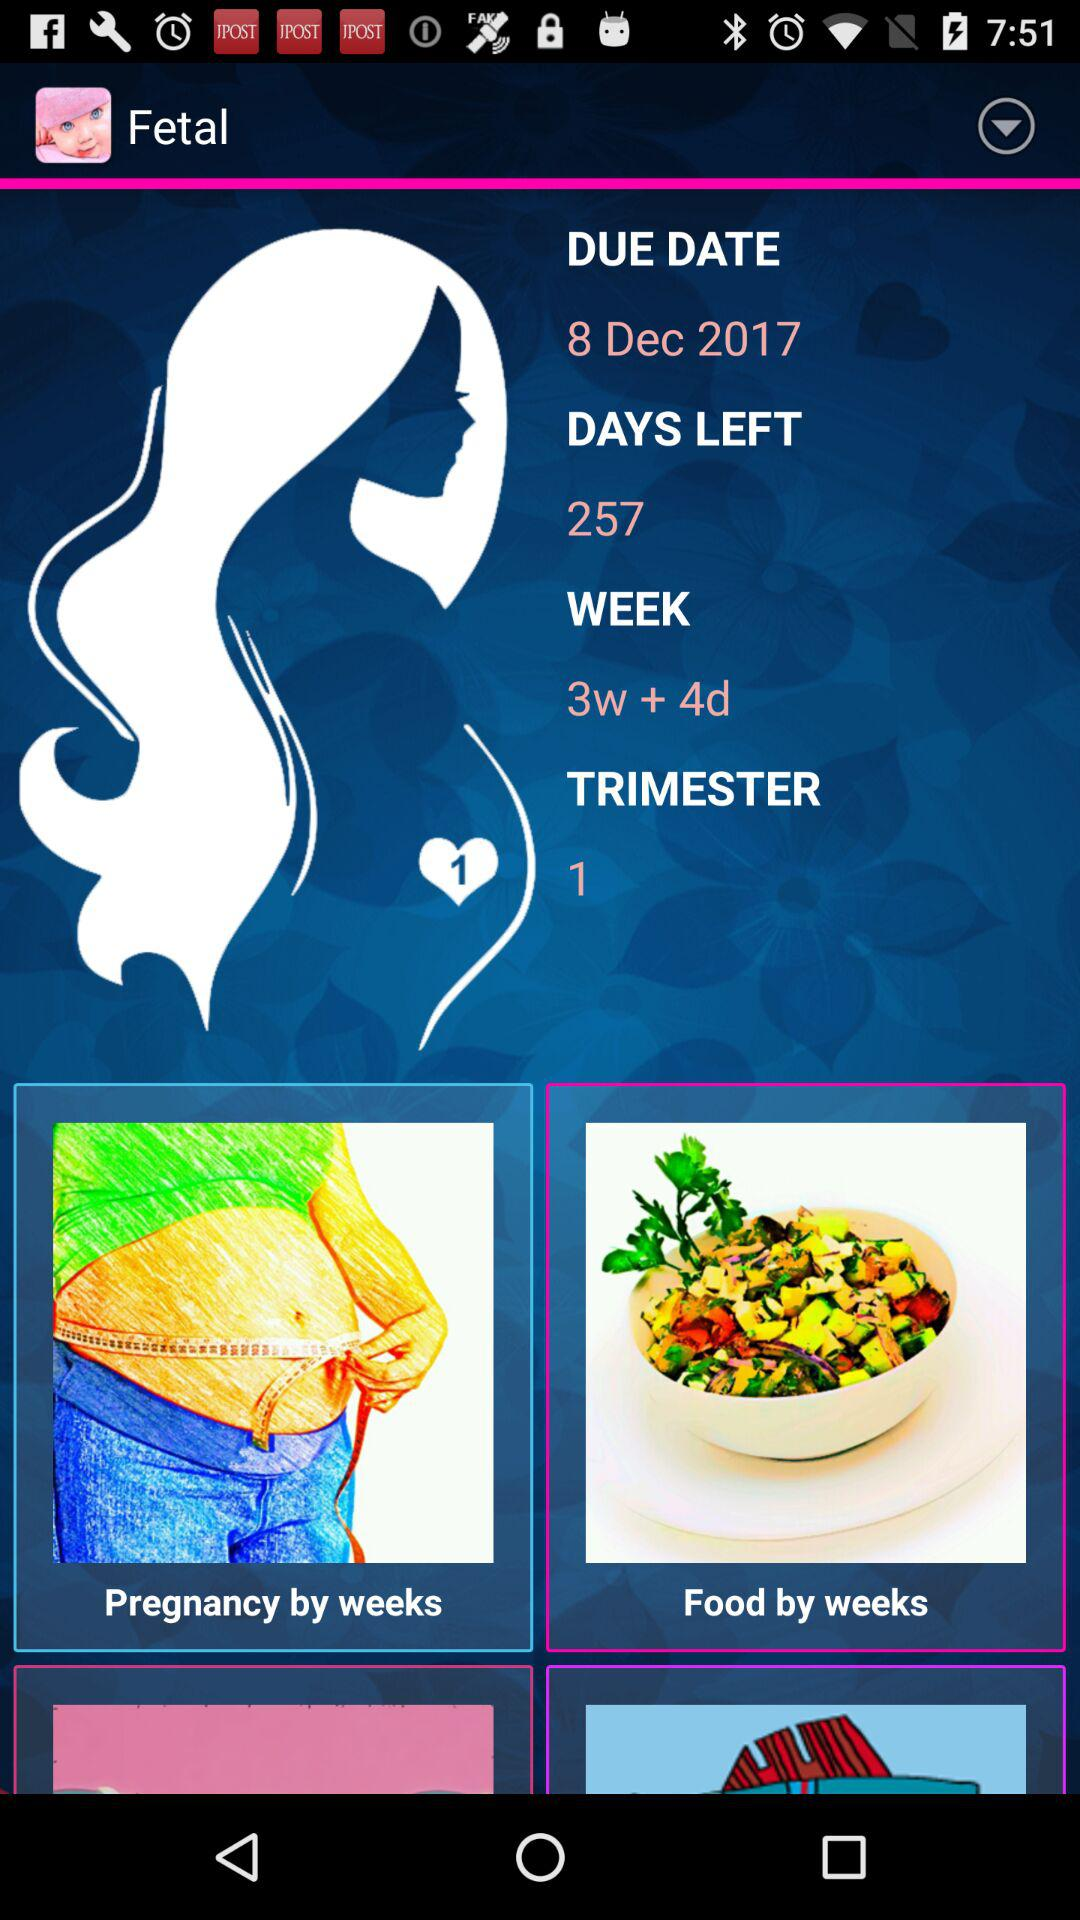What's the due date? The due date is December 8, 2017. 